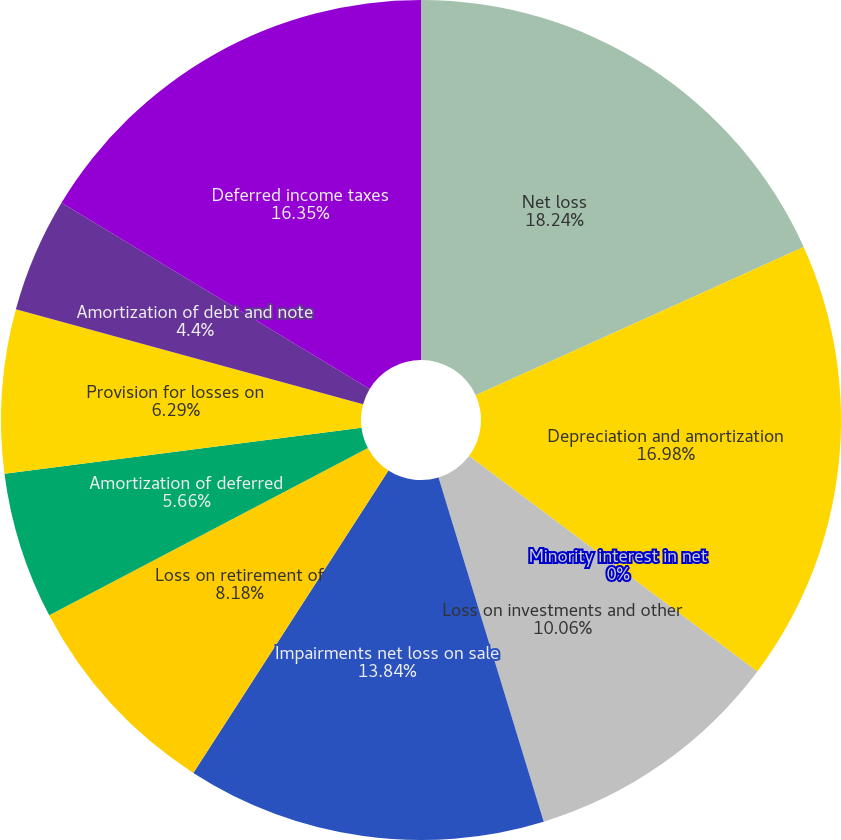Convert chart. <chart><loc_0><loc_0><loc_500><loc_500><pie_chart><fcel>Net loss<fcel>Depreciation and amortization<fcel>Minority interest in net<fcel>Loss on investments and other<fcel>Impairments net loss on sale<fcel>Loss on retirement of<fcel>Amortization of deferred<fcel>Provision for losses on<fcel>Amortization of debt and note<fcel>Deferred income taxes<nl><fcel>18.24%<fcel>16.98%<fcel>0.0%<fcel>10.06%<fcel>13.84%<fcel>8.18%<fcel>5.66%<fcel>6.29%<fcel>4.4%<fcel>16.35%<nl></chart> 